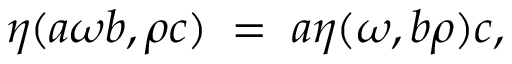<formula> <loc_0><loc_0><loc_500><loc_500>\eta ( a \omega b , \rho c ) \, = \, a \eta ( \omega , b \rho ) c ,</formula> 